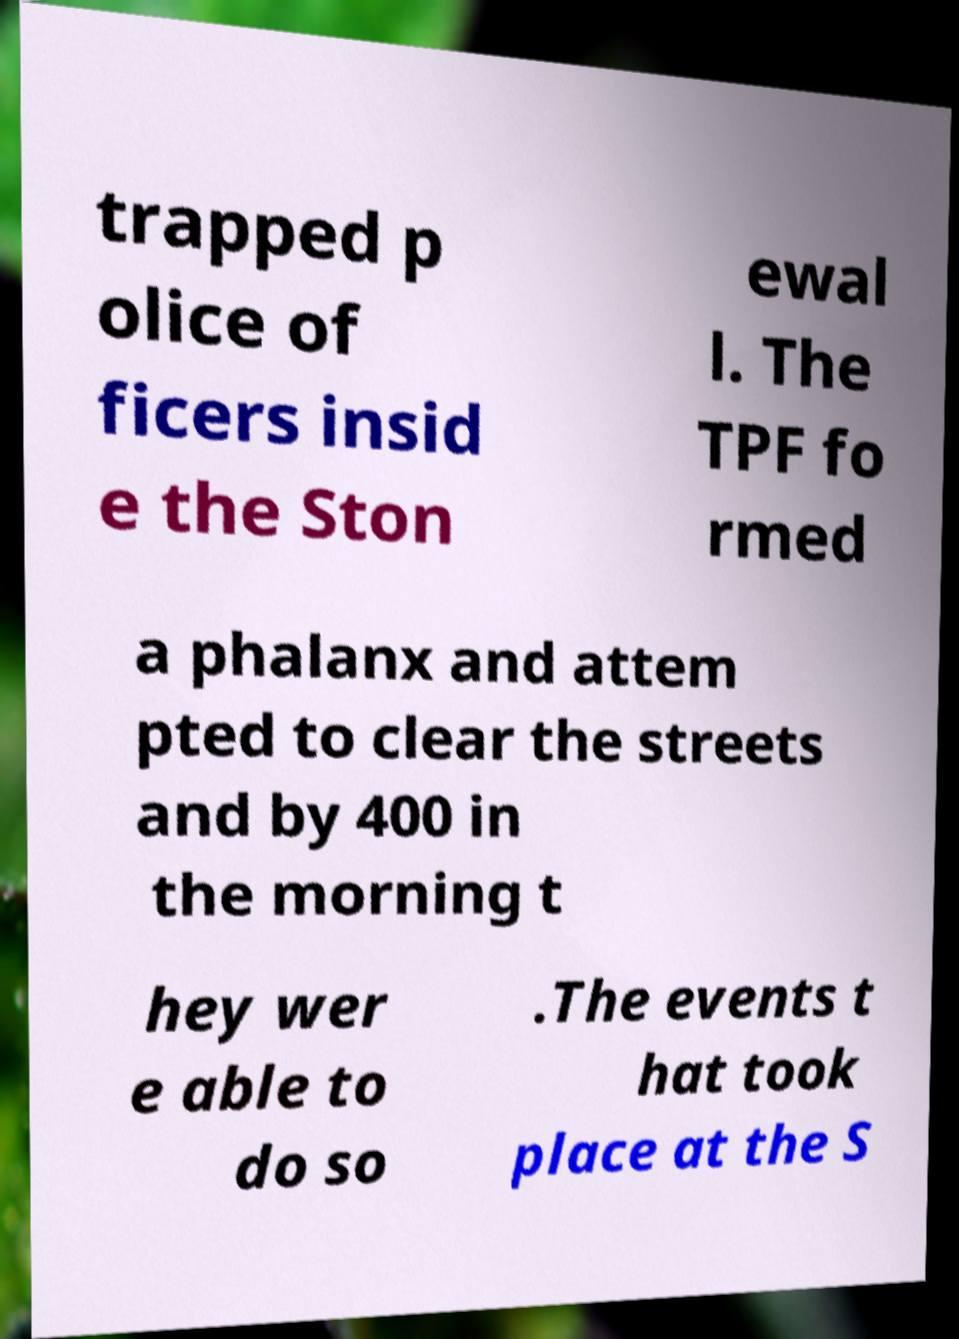Can you read and provide the text displayed in the image?This photo seems to have some interesting text. Can you extract and type it out for me? trapped p olice of ficers insid e the Ston ewal l. The TPF fo rmed a phalanx and attem pted to clear the streets and by 400 in the morning t hey wer e able to do so .The events t hat took place at the S 